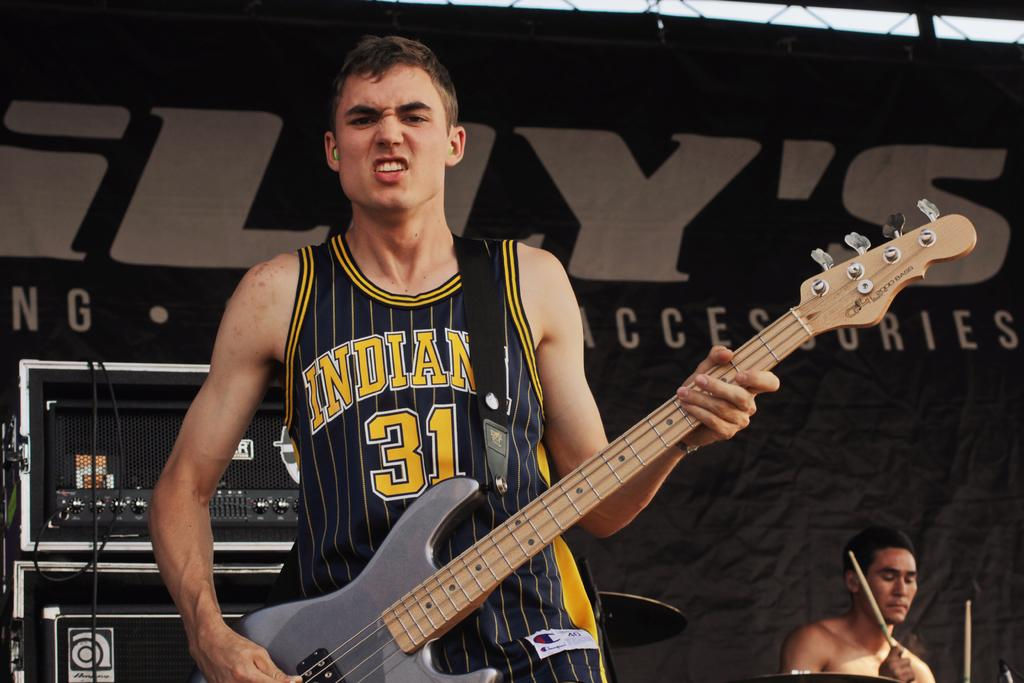<image>
Present a compact description of the photo's key features. A man wearing a yellow and black tank top with the number 31 in the middle. 